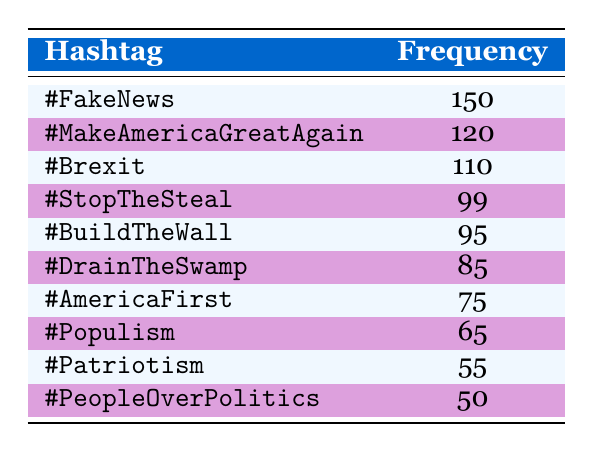What is the most frequently used hashtag in populist rhetoric? The table lists the hashtags along with their frequencies. By scanning the "Frequency" column, I can see that the highest value is 150, which corresponds to the hashtag "#FakeNews".
Answer: #FakeNews How many times was the hashtag "#MakeAmericaGreatAgain" used? The "Frequency" column shows that "#MakeAmericaGreatAgain" was used 120 times.
Answer: 120 What is the total frequency of the hashtags "#DrainTheSwamp" and "#Brexit"? To find the total, I add the frequencies of "#DrainTheSwamp" (85) and "#Brexit" (110). 85 + 110 = 195.
Answer: 195 Is the frequency of "#AmericaFirst" greater than that of "#PeopleOverPolitics"? "#AmericaFirst" has a frequency of 75 while "#PeopleOverPolitics" has a frequency of 50. Since 75 is greater than 50, the statement is true.
Answer: Yes What is the average frequency of the hashtags listed in the table? There are 10 hashtags in total. I calculate the sum of their frequencies: (150 + 120 + 110 + 99 + 95 + 85 + 75 + 65 + 55 + 50) = 1024. To find the average, I divide the total by the number of hashtags: 1024 / 10 = 102.4.
Answer: 102.4 Which hashtag has the second lowest frequency and what is that frequency? The table shows that the hashtags are listed from highest to lowest frequency. Scanning the list, the second lowest frequency is of the hashtag "#PeopleOverPolitics" with a frequency of 50.
Answer: #PeopleOverPolitics, 50 If you combine the frequencies of the three most used hashtags, what would that total be? The three most used hashtags are "#FakeNews" (150), "#MakeAmericaGreatAgain" (120), and "#Brexit" (110). Adding these together gives: 150 + 120 + 110 = 380.
Answer: 380 What percentage of the total frequency does "#StopTheSteal" represent? The frequency of "#StopTheSteal" is 99. The total frequency of all hashtags is 1024. To find the percentage: (99 / 1024) * 100 = approximately 9.67%.
Answer: 9.67% Is there any hashtag that was used less than 60 times? The table shows the frequencies of all hashtags. The lowest frequency is 50 for "#PeopleOverPolitics", which is indeed less than 60. Therefore, the answer is yes.
Answer: Yes 